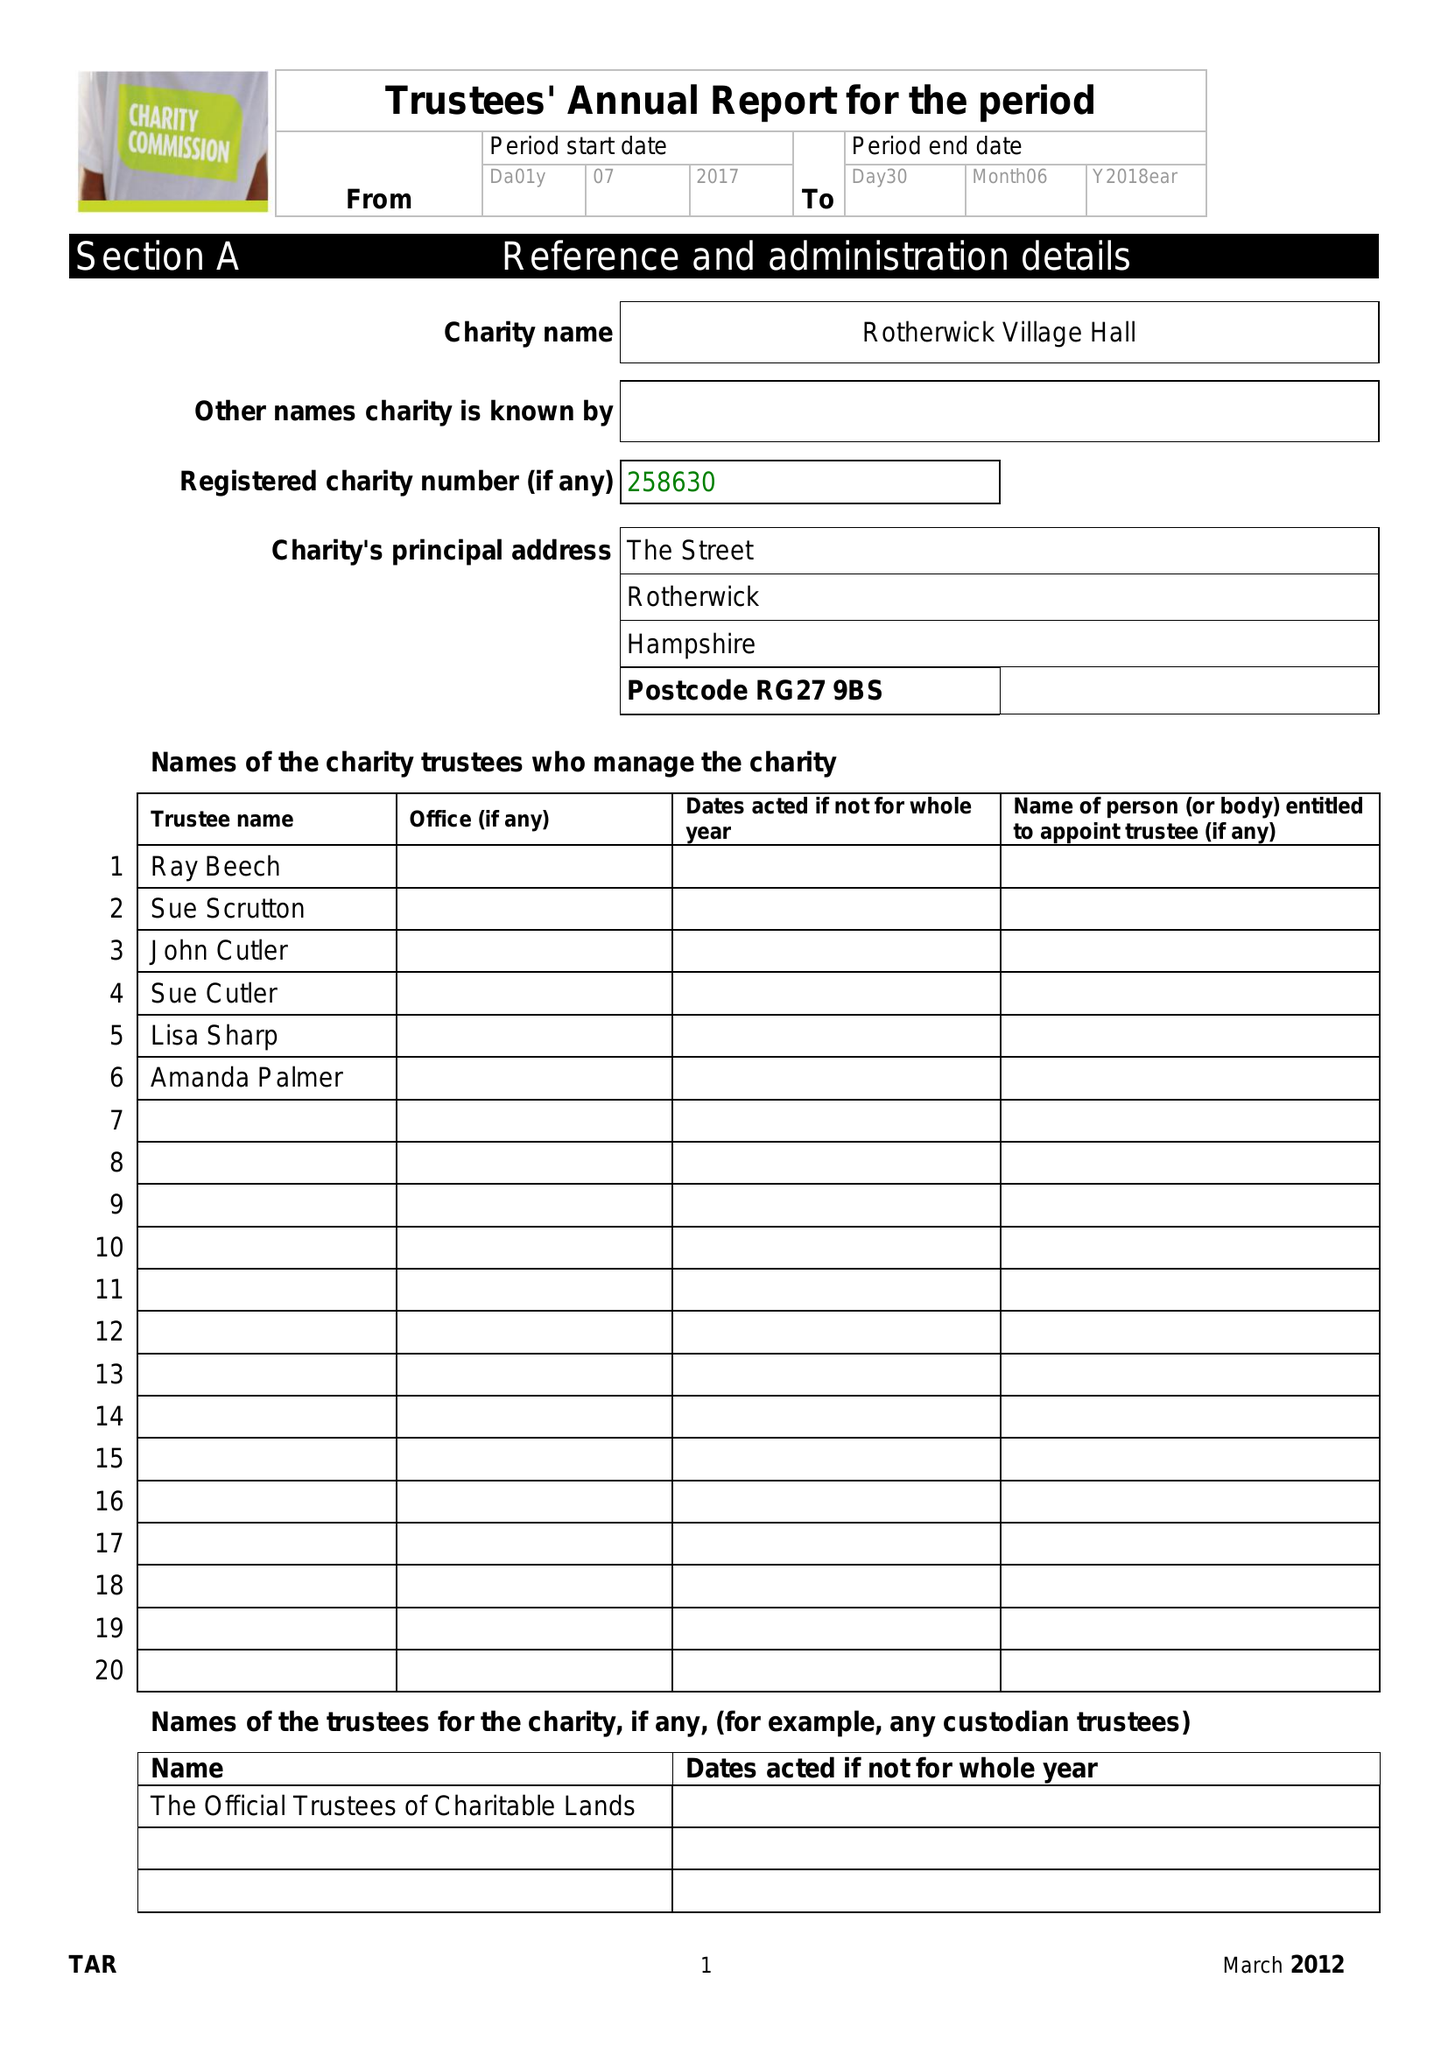What is the value for the income_annually_in_british_pounds?
Answer the question using a single word or phrase. 33009.00 